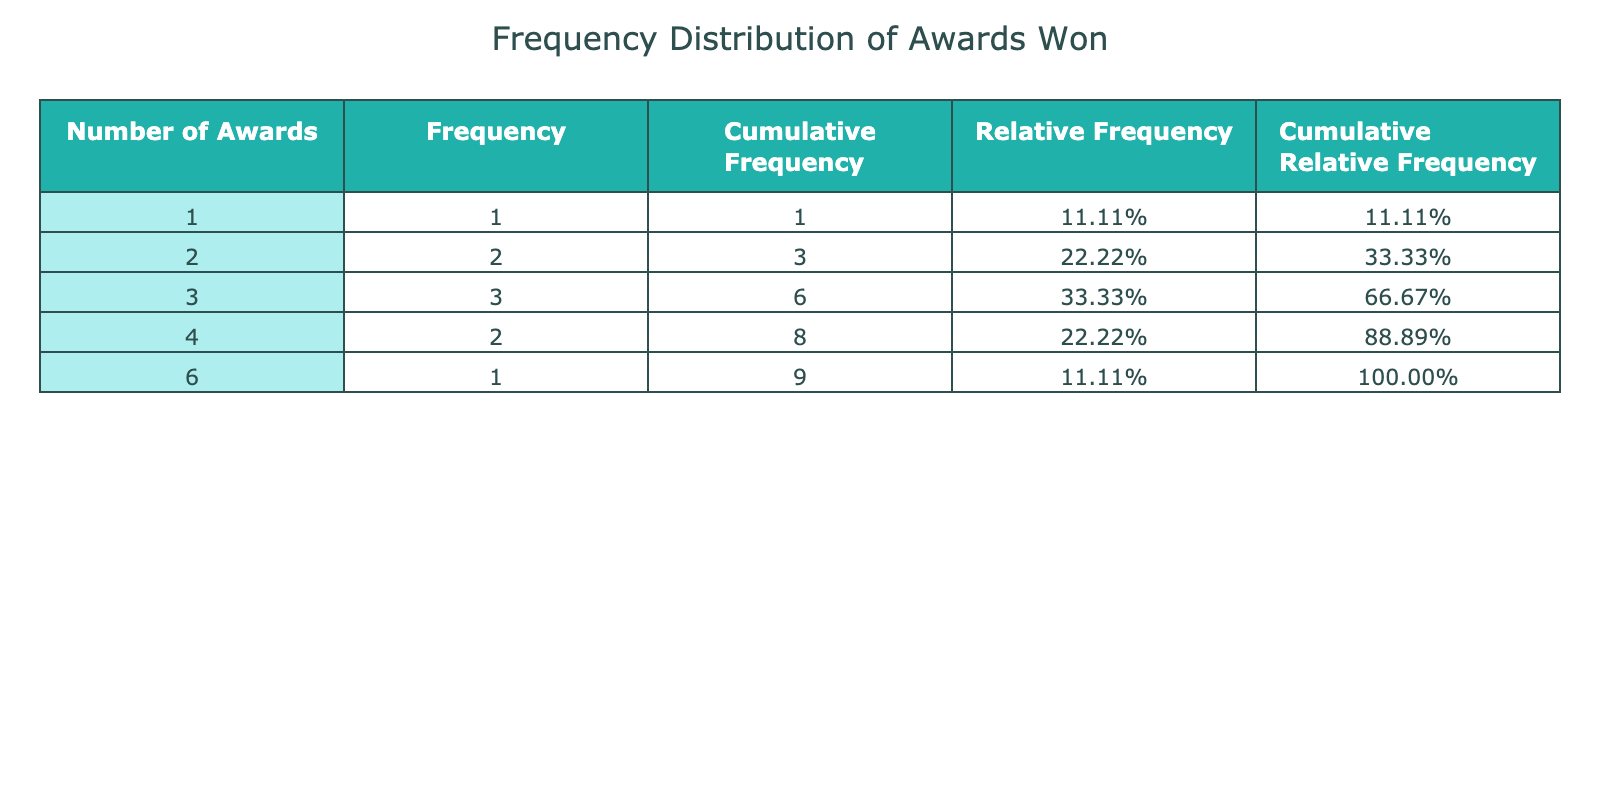What is the mode of the number of awards won? The mode is the value that appears most frequently in the data. Here, the frequencies show that the number of awards won is 3, which occurs 4 times (for "Moonlight", "1917", "The Power of the Dog").
Answer: 3 How many films won more than 3 awards? We need to look at the number of awards won and count the films with more than 3. From the table, "Nomadland" won 6 awards, and "Birdman" and "Parasite" won 4 awards. Three films in total won more than 3 awards.
Answer: 3 What is the cumulative frequency for films that won 2 awards? The cumulative frequency is the sum of all frequencies up to and including a specific category. The frequency for 2 awards is 2 ("Director's Cut" and "Don't Look Up"). So, the cumulative frequency at 2 is 2.
Answer: 2 Is there a film that won exactly 1 award? To answer this, we check if the frequency for 1 award is greater than zero. The table indicates that "Licorice Pizza" won exactly 1 award, so the statement is true.
Answer: Yes What is the average number of awards won by films in this table? To find the average, we sum all the awards won: (4 + 3 + 4 + 3 + 6 + 3 + 2 + 2 + 1) = 28. Since there are 9 films, we divide 28 by 9, which yields approximately 3.11.
Answer: 3.11 How many films won at least 2 awards? We need to count the films that won 2 awards or more. Counting from the table, the films with 2 or more awards are "Birdman," "Moonlight," "Parasite," "1917," "Nomadland," "The Power of the Dog," "Director's Cut," and "Don't Look Up," totaling 8 films.
Answer: 8 What percentage of films won more than 4 awards? The total number of films is 9. The films that won more than 4 awards are "Nomadland," "Birdman," and "Parasite," which totals to 3 films. To find the percentage, we do (3/9) * 100 = 33.33%.
Answer: 33.33% How many films have a relative frequency greater than 20%? First, let's see the relative frequencies from the table. The frequencies are: 1 award (1), 2 awards (2), 3 awards (4), 4 awards (3), and 6 awards (1). Calculating their relative frequencies: 1/9, 2/9 (22.22%), 3/9 (33.33%), 4/9 (44.44%), and 6/9 (66.67%). Thus, 5 films have a relative frequency greater than 20%.
Answer: 5 